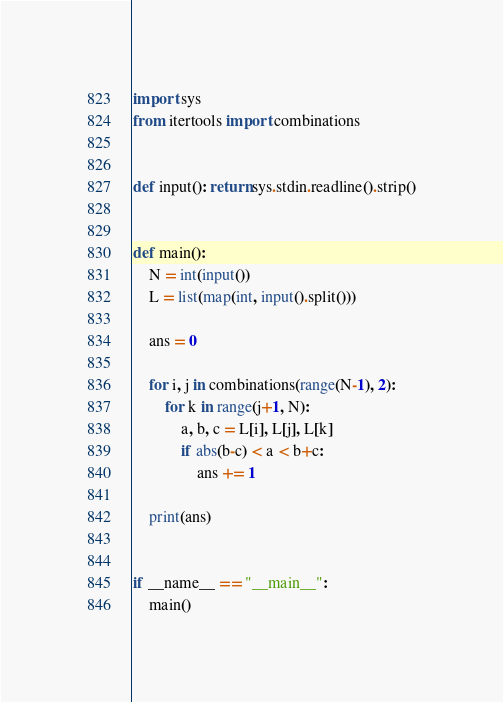Convert code to text. <code><loc_0><loc_0><loc_500><loc_500><_Python_>import sys
from itertools import combinations


def input(): return sys.stdin.readline().strip()


def main():
    N = int(input())
    L = list(map(int, input().split()))

    ans = 0

    for i, j in combinations(range(N-1), 2):
        for k in range(j+1, N):
            a, b, c = L[i], L[j], L[k]
            if abs(b-c) < a < b+c:
                ans += 1

    print(ans)


if __name__ == "__main__":
    main()
</code> 